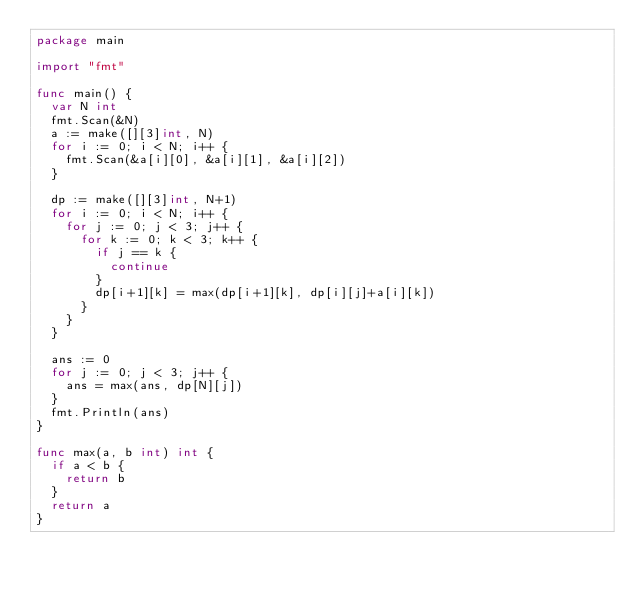<code> <loc_0><loc_0><loc_500><loc_500><_Go_>package main

import "fmt"

func main() {
	var N int
	fmt.Scan(&N)
	a := make([][3]int, N)
	for i := 0; i < N; i++ {
		fmt.Scan(&a[i][0], &a[i][1], &a[i][2])
	}

	dp := make([][3]int, N+1)
	for i := 0; i < N; i++ {
		for j := 0; j < 3; j++ {
			for k := 0; k < 3; k++ {
				if j == k {
					continue
				}
				dp[i+1][k] = max(dp[i+1][k], dp[i][j]+a[i][k])
			}
		}
	}

	ans := 0
	for j := 0; j < 3; j++ {
		ans = max(ans, dp[N][j])
	}
	fmt.Println(ans)
}

func max(a, b int) int {
	if a < b {
		return b
	}
	return a
}
</code> 